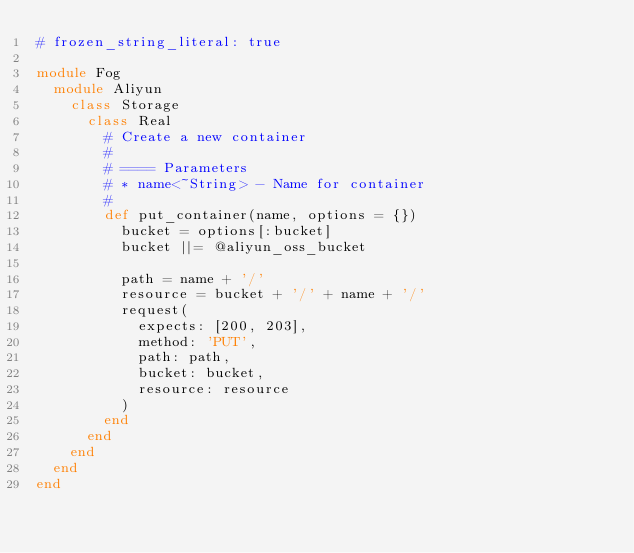<code> <loc_0><loc_0><loc_500><loc_500><_Ruby_># frozen_string_literal: true

module Fog
  module Aliyun
    class Storage
      class Real
        # Create a new container
        #
        # ==== Parameters
        # * name<~String> - Name for container
        #
        def put_container(name, options = {})
          bucket = options[:bucket]
          bucket ||= @aliyun_oss_bucket

          path = name + '/'
          resource = bucket + '/' + name + '/'
          request(
            expects: [200, 203],
            method: 'PUT',
            path: path,
            bucket: bucket,
            resource: resource
          )
        end
      end
    end
  end
end
</code> 